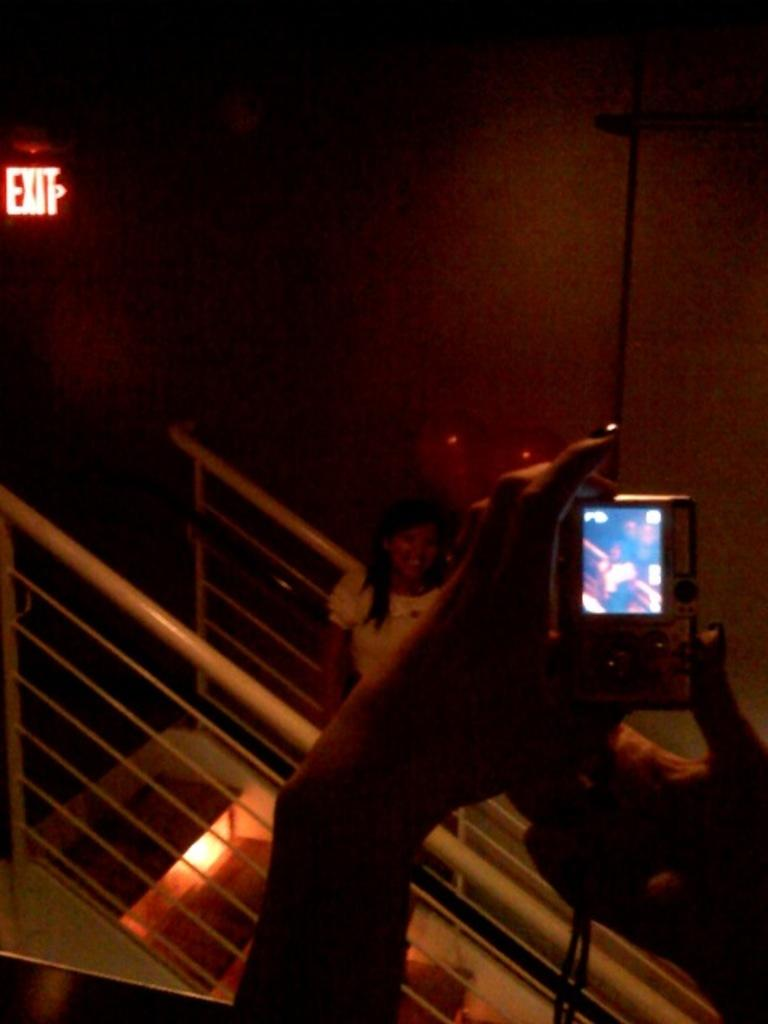<image>
Give a short and clear explanation of the subsequent image. a girl posing near an exit sign for the camera 